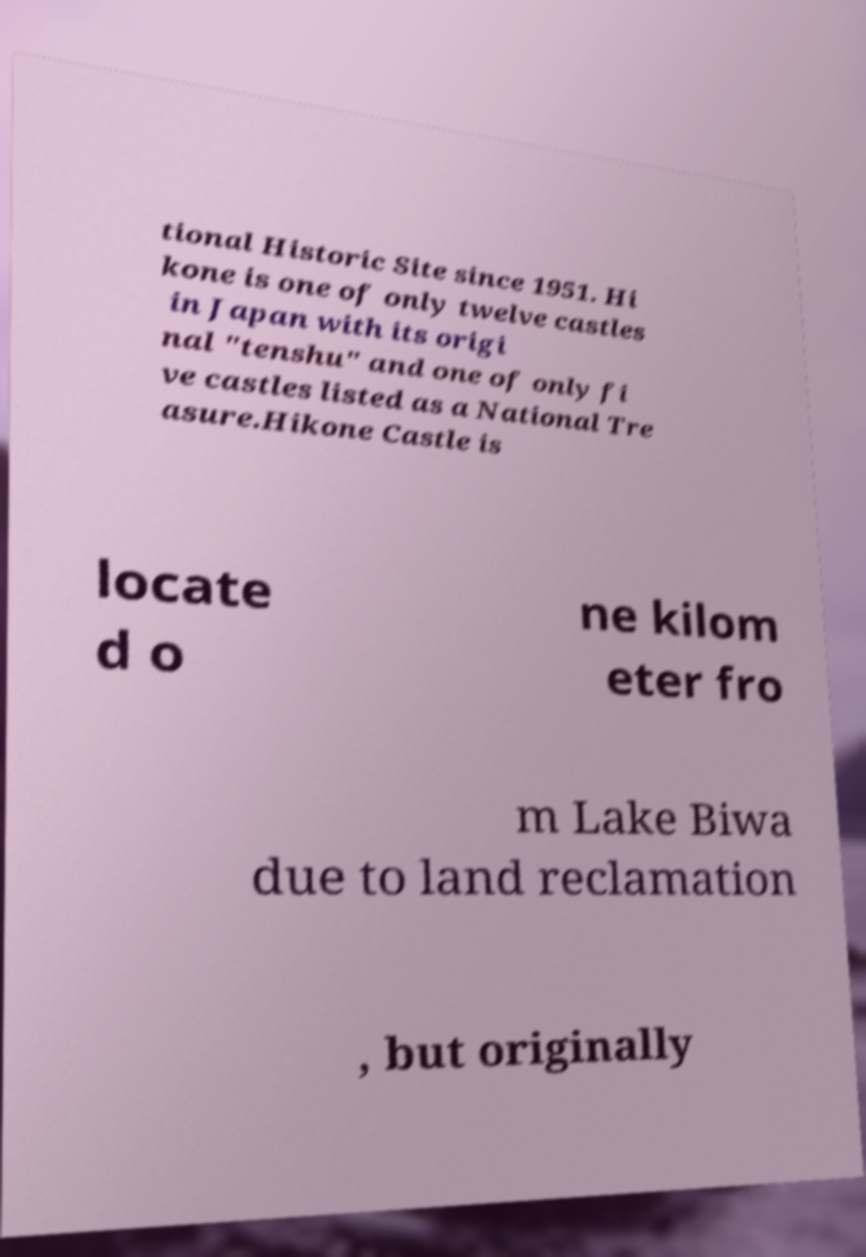I need the written content from this picture converted into text. Can you do that? tional Historic Site since 1951. Hi kone is one of only twelve castles in Japan with its origi nal "tenshu" and one of only fi ve castles listed as a National Tre asure.Hikone Castle is locate d o ne kilom eter fro m Lake Biwa due to land reclamation , but originally 